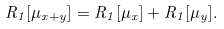<formula> <loc_0><loc_0><loc_500><loc_500>R _ { 1 } [ \mu _ { x + y } ] = R _ { 1 } [ \mu _ { x } ] + R _ { 1 } [ \mu _ { y } ] .</formula> 